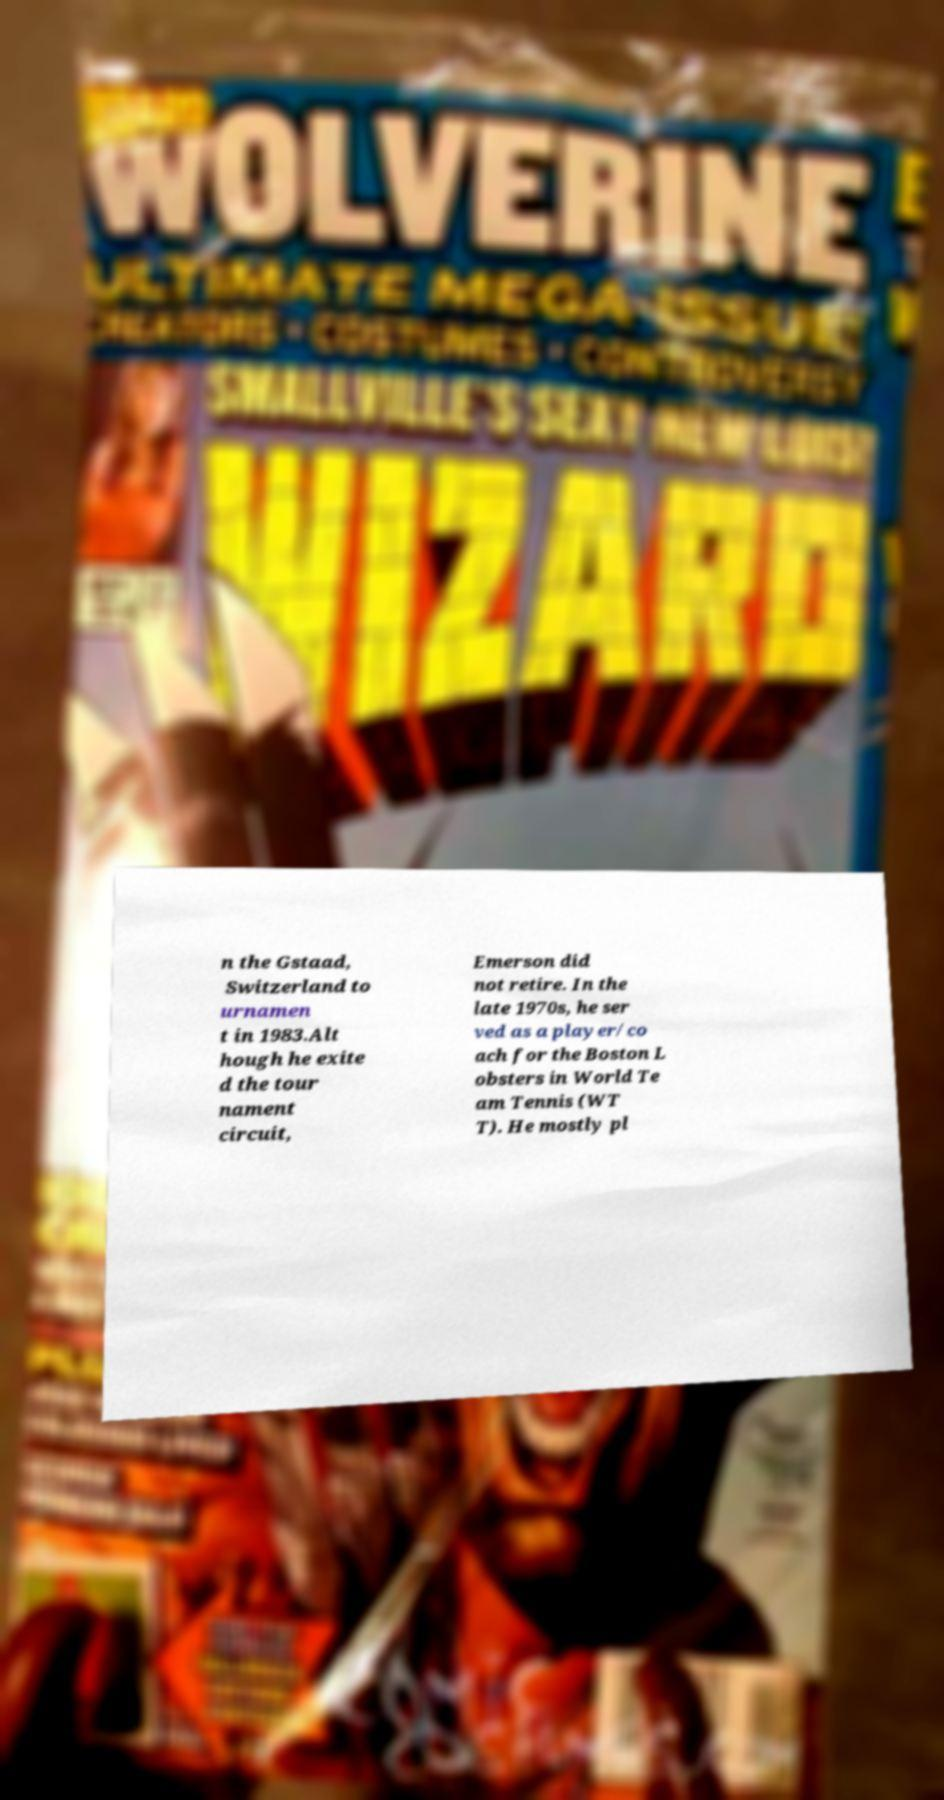What messages or text are displayed in this image? I need them in a readable, typed format. n the Gstaad, Switzerland to urnamen t in 1983.Alt hough he exite d the tour nament circuit, Emerson did not retire. In the late 1970s, he ser ved as a player/co ach for the Boston L obsters in World Te am Tennis (WT T). He mostly pl 